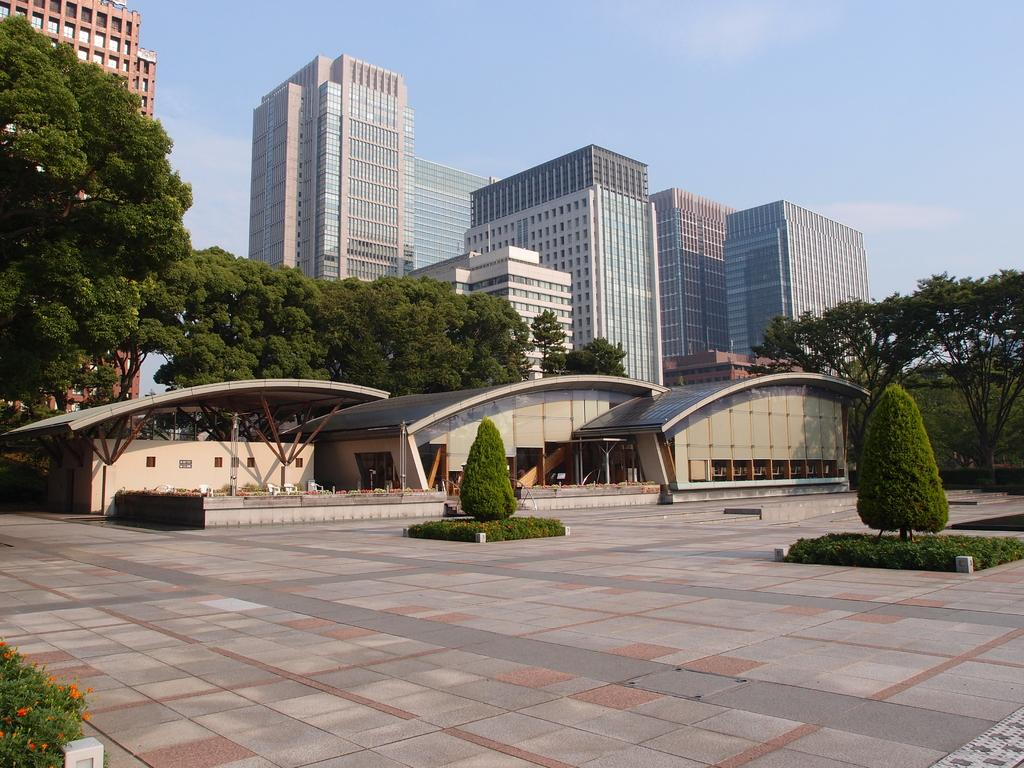What type of vegetation is present on the ground in the image? There are plants on the ground in the image. What other natural elements can be seen in the image? There are trees in the image. What type of man-made structures are visible in the image? There are buildings in the image. What type of furniture is present in the image? There are chairs in the image. What else can be seen in the image besides the plants, trees, buildings, and chairs? There are some objects in the image. What is visible in the background of the image? The sky is visible in the background of the image. What type of friction can be observed between the plants and the ground in the image? There is no specific friction mentioned or observable between the plants and the ground in the image. Is there a hospital visible in the image? There is no mention of a hospital or any medical facility in the image. 